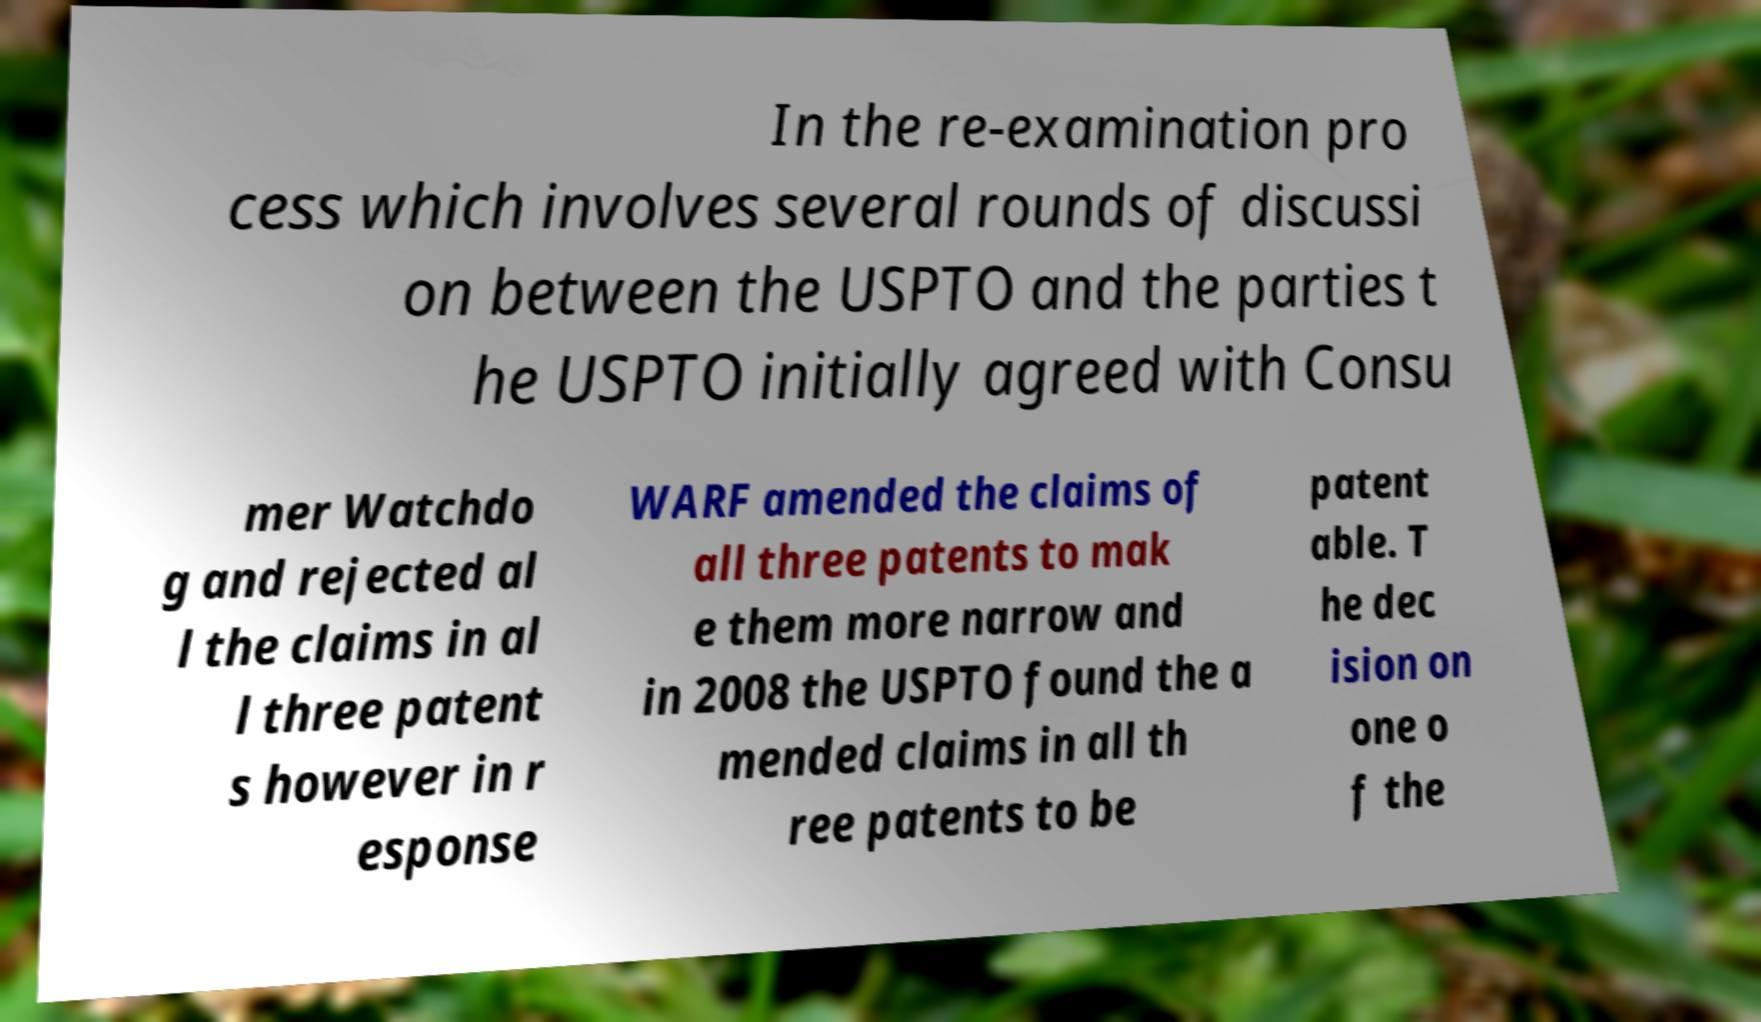Could you extract and type out the text from this image? In the re-examination pro cess which involves several rounds of discussi on between the USPTO and the parties t he USPTO initially agreed with Consu mer Watchdo g and rejected al l the claims in al l three patent s however in r esponse WARF amended the claims of all three patents to mak e them more narrow and in 2008 the USPTO found the a mended claims in all th ree patents to be patent able. T he dec ision on one o f the 